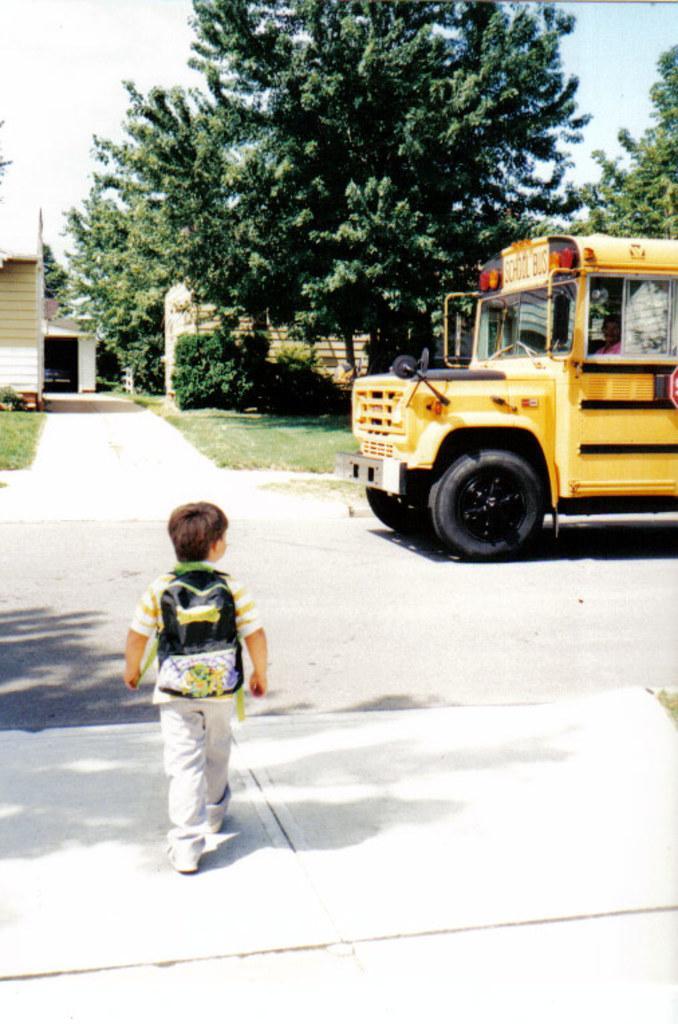How would you summarize this image in a sentence or two? In this image we can see a person, vehicle, road and other objects. In the background of the image there is a building, trees, sky, grass, walkway and other objects. At the bottom of the image there is the floor. 